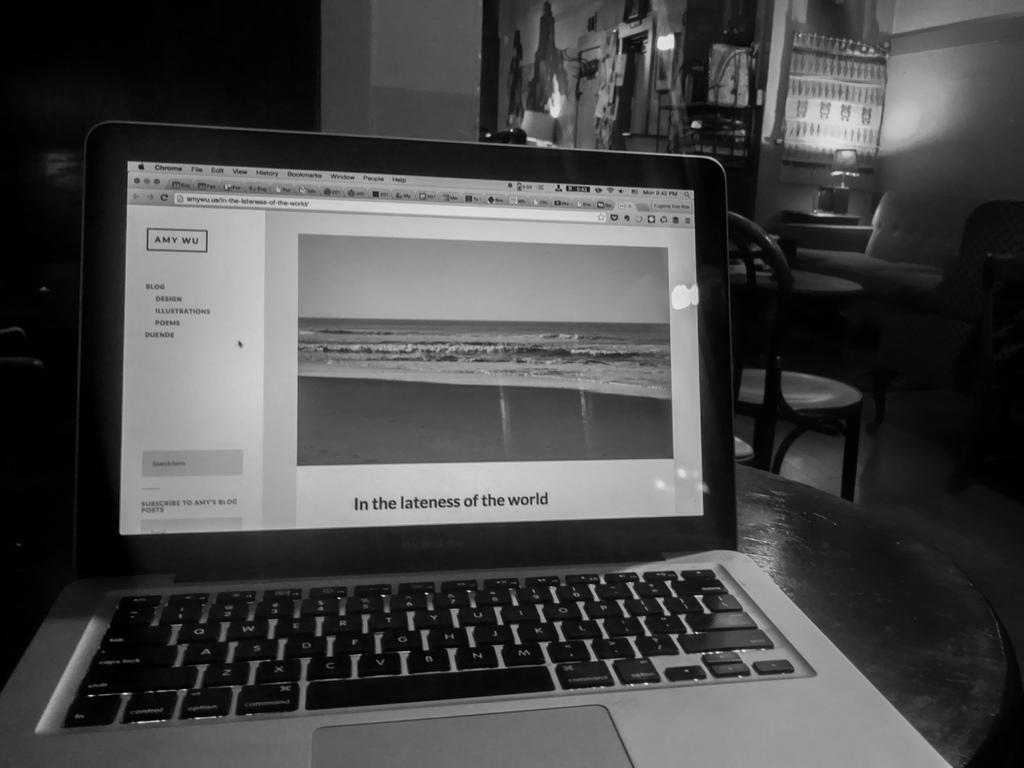<image>
Describe the image concisely. A black and white laptop with In the lateness of the world on the screen 